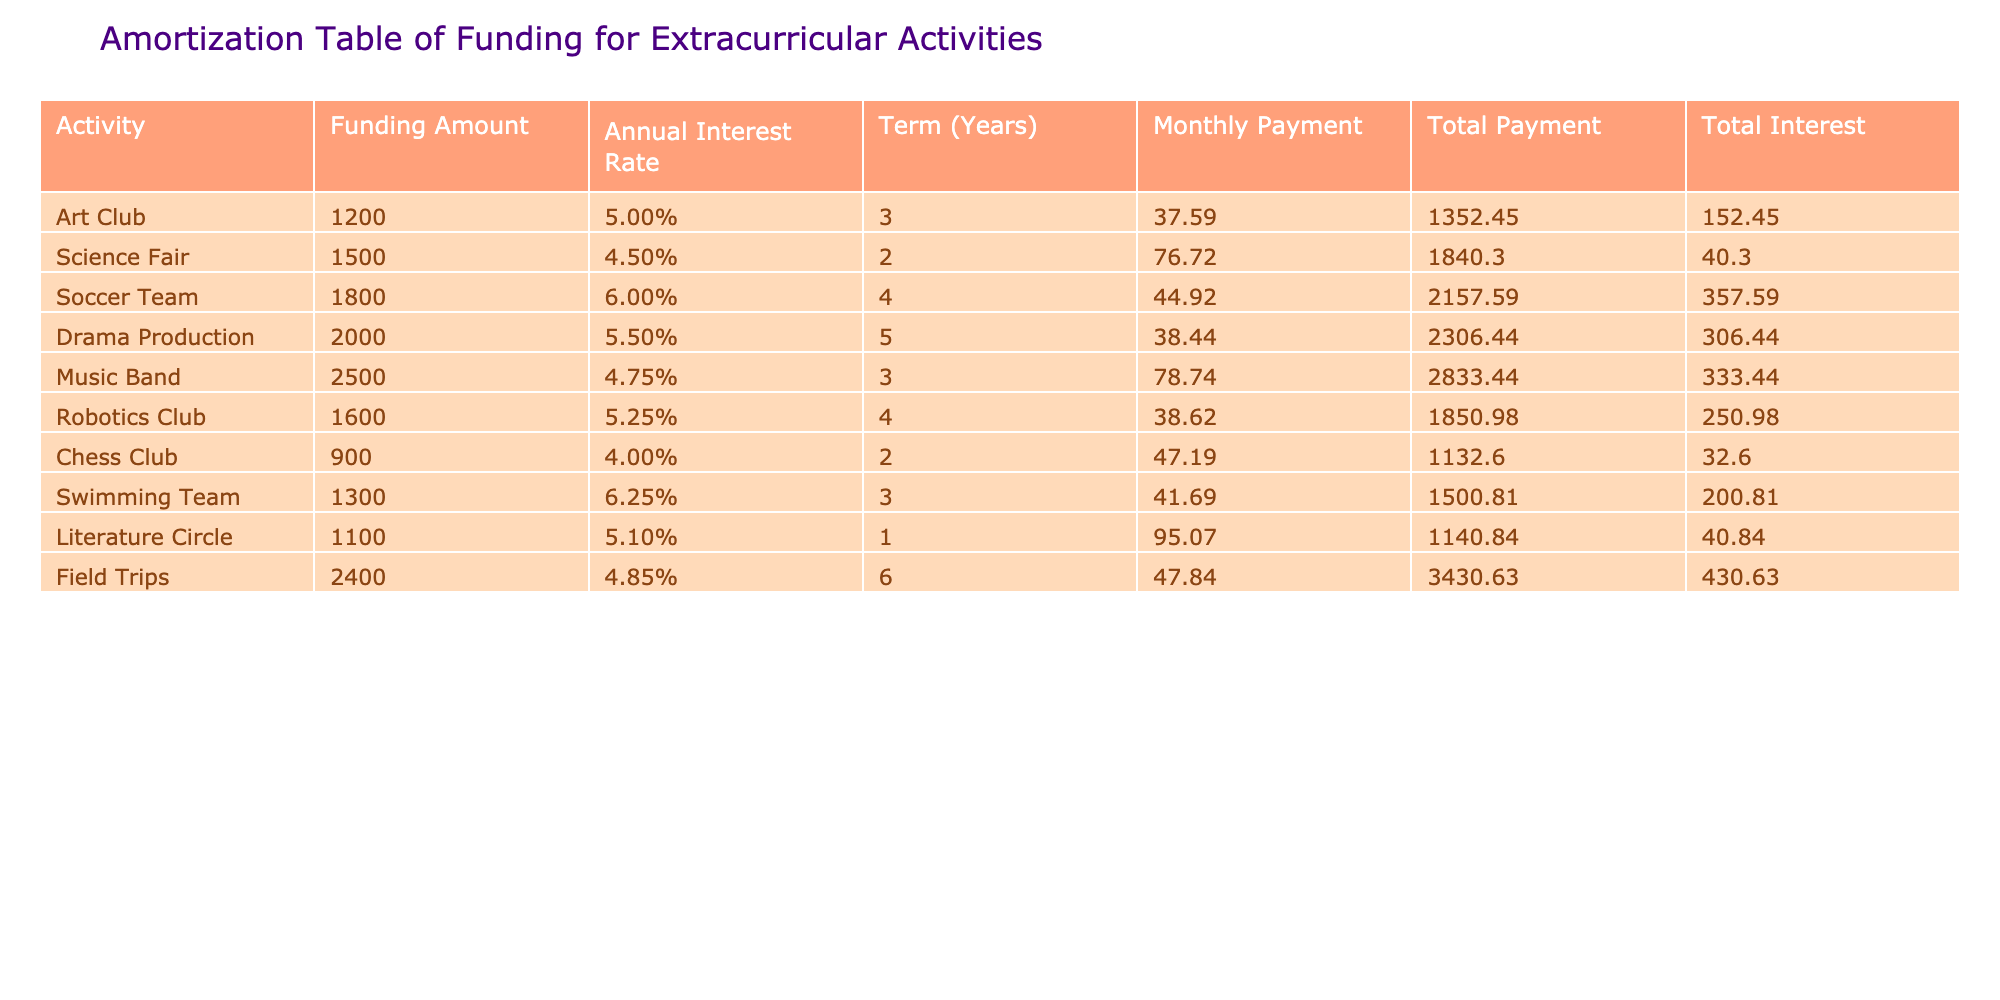What is the monthly payment for the Science Fair? The monthly payment for the Science Fair is provided directly in the table under the Monthly Payment column corresponding to the Science Fair row. Hence, it is 76.72.
Answer: 76.72 Which activity has the highest total interest? Look at the Total Interest column and identify the value with the highest number. The Soccer Team has a total interest of 357.59, which is the highest compared to the other activities.
Answer: 357.59 What is the total payment for the Music Band activity? The Total Payment for the Music Band can be directly found in the Total Payment column. The value listed for the Music Band is 2833.44.
Answer: 2833.44 Is the funding amount for the Drama Production greater than the total payment for the Chess Club? For the Drama Production, the funding amount is 2000, and for the Chess Club, the total payment is 1132.60. Since 2000 is greater than 1132.60, the answer is yes.
Answer: Yes What is the average total interest across all activities? First, sum the total interest for all activities by adding the values (152.45 + 40.30 + 357.59 + 306.44 + 333.44 + 250.98 + 32.60 + 200.81 + 40.84 + 430.63) = 1945.14. Then divide by the number of activities which is 10. So, 1945.14 / 10 = 194.514, rounded gives approximately 194.51.
Answer: 194.51 What is the total funding amount for activities with a term of 2 years? Identify the activities with a term of 2 (Science Fair and Chess Club), and add their funding amounts (1500 + 900) = 2400.
Answer: 2400 Does the Swimming Team have a lower annual interest rate than the Art Club? The Swimming Team has an annual interest rate of 6.25%, and the Art Club has an annual interest rate of 5.00%. Since 6.25% is higher than 5.00%, the answer is no.
Answer: No Which activity requires the least monthly payment? The Monthly Payment column shows the payments for each activity. From looking at the values, the one with the least payment is the Robotics Club, which has a monthly payment of 38.62.
Answer: 38.62 